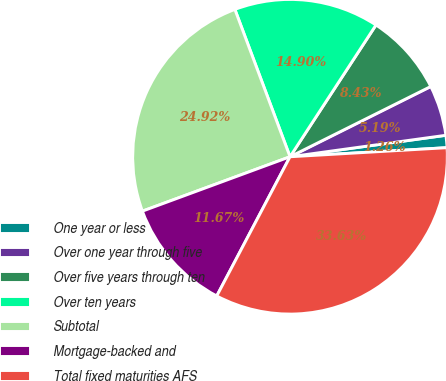<chart> <loc_0><loc_0><loc_500><loc_500><pie_chart><fcel>One year or less<fcel>Over one year through five<fcel>Over five years through ten<fcel>Over ten years<fcel>Subtotal<fcel>Mortgage-backed and<fcel>Total fixed maturities AFS<nl><fcel>1.26%<fcel>5.19%<fcel>8.43%<fcel>14.9%<fcel>24.92%<fcel>11.67%<fcel>33.63%<nl></chart> 